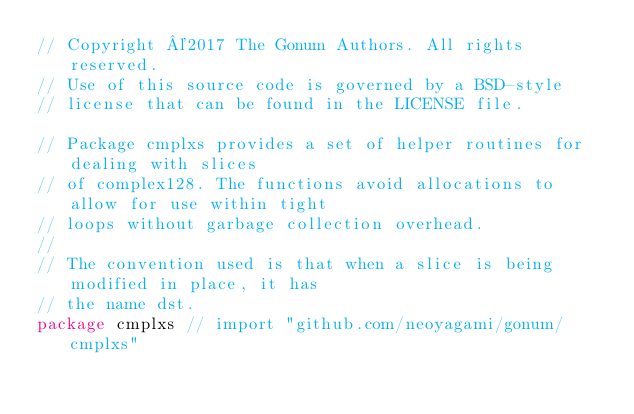Convert code to text. <code><loc_0><loc_0><loc_500><loc_500><_Go_>// Copyright ©2017 The Gonum Authors. All rights reserved.
// Use of this source code is governed by a BSD-style
// license that can be found in the LICENSE file.

// Package cmplxs provides a set of helper routines for dealing with slices
// of complex128. The functions avoid allocations to allow for use within tight
// loops without garbage collection overhead.
//
// The convention used is that when a slice is being modified in place, it has
// the name dst.
package cmplxs // import "github.com/neoyagami/gonum/cmplxs"
</code> 